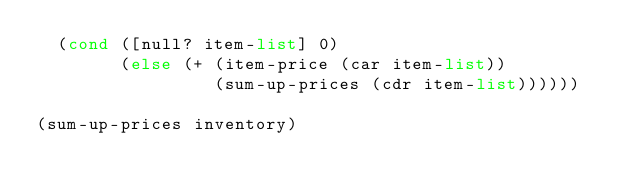Convert code to text. <code><loc_0><loc_0><loc_500><loc_500><_Racket_>  (cond ([null? item-list] 0)
        (else (+ (item-price (car item-list))
                 (sum-up-prices (cdr item-list))))))

(sum-up-prices inventory)
</code> 